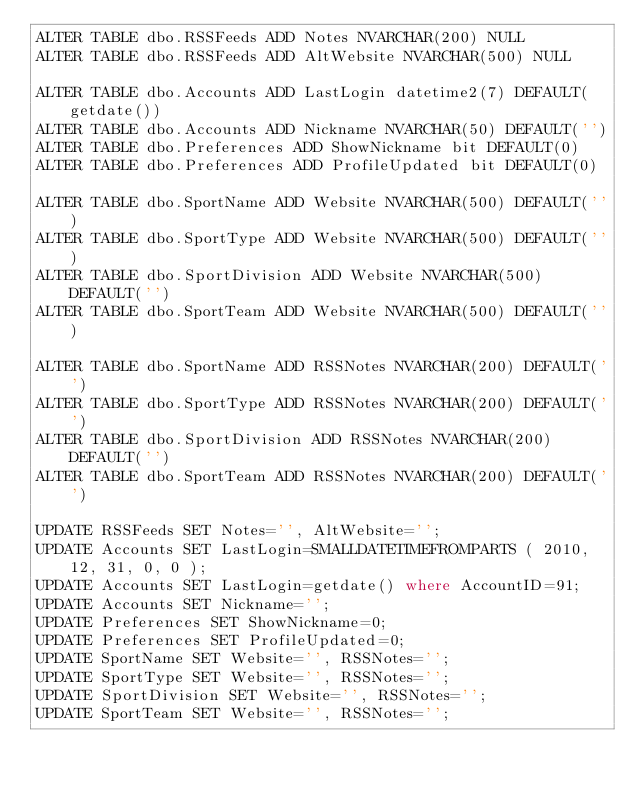Convert code to text. <code><loc_0><loc_0><loc_500><loc_500><_SQL_>ALTER TABLE dbo.RSSFeeds ADD Notes NVARCHAR(200) NULL
ALTER TABLE dbo.RSSFeeds ADD AltWebsite NVARCHAR(500) NULL

ALTER TABLE dbo.Accounts ADD LastLogin datetime2(7) DEFAULT(getdate())
ALTER TABLE dbo.Accounts ADD Nickname NVARCHAR(50) DEFAULT('')
ALTER TABLE dbo.Preferences ADD ShowNickname bit DEFAULT(0)
ALTER TABLE dbo.Preferences ADD ProfileUpdated bit DEFAULT(0)

ALTER TABLE dbo.SportName ADD Website NVARCHAR(500) DEFAULT('')
ALTER TABLE dbo.SportType ADD Website NVARCHAR(500) DEFAULT('')
ALTER TABLE dbo.SportDivision ADD Website NVARCHAR(500) DEFAULT('')
ALTER TABLE dbo.SportTeam ADD Website NVARCHAR(500) DEFAULT('')

ALTER TABLE dbo.SportName ADD RSSNotes NVARCHAR(200) DEFAULT('')
ALTER TABLE dbo.SportType ADD RSSNotes NVARCHAR(200) DEFAULT('')
ALTER TABLE dbo.SportDivision ADD RSSNotes NVARCHAR(200) DEFAULT('')
ALTER TABLE dbo.SportTeam ADD RSSNotes NVARCHAR(200) DEFAULT('')

UPDATE RSSFeeds SET Notes='', AltWebsite='';
UPDATE Accounts SET LastLogin=SMALLDATETIMEFROMPARTS ( 2010, 12, 31, 0, 0 );
UPDATE Accounts SET LastLogin=getdate() where AccountID=91;
UPDATE Accounts SET Nickname='';
UPDATE Preferences SET ShowNickname=0;
UPDATE Preferences SET ProfileUpdated=0;
UPDATE SportName SET Website='', RSSNotes='';
UPDATE SportType SET Website='', RSSNotes='';
UPDATE SportDivision SET Website='', RSSNotes='';
UPDATE SportTeam SET Website='', RSSNotes='';

</code> 